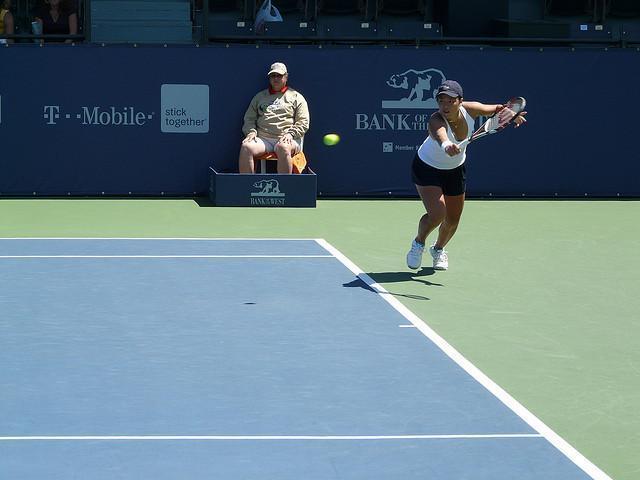How many people are in the picture?
Give a very brief answer. 2. How many people are there?
Give a very brief answer. 2. 